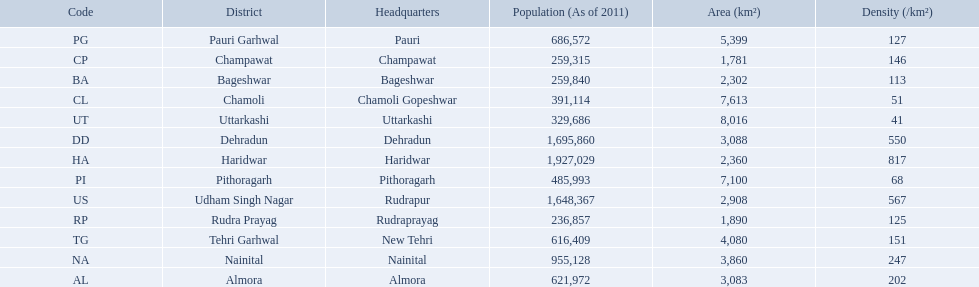What are the names of all the districts? Almora, Bageshwar, Chamoli, Champawat, Dehradun, Haridwar, Nainital, Pauri Garhwal, Pithoragarh, Rudra Prayag, Tehri Garhwal, Udham Singh Nagar, Uttarkashi. What range of densities do these districts encompass? 202, 113, 51, 146, 550, 817, 247, 127, 68, 125, 151, 567, 41. Which district has a density of 51? Chamoli. 